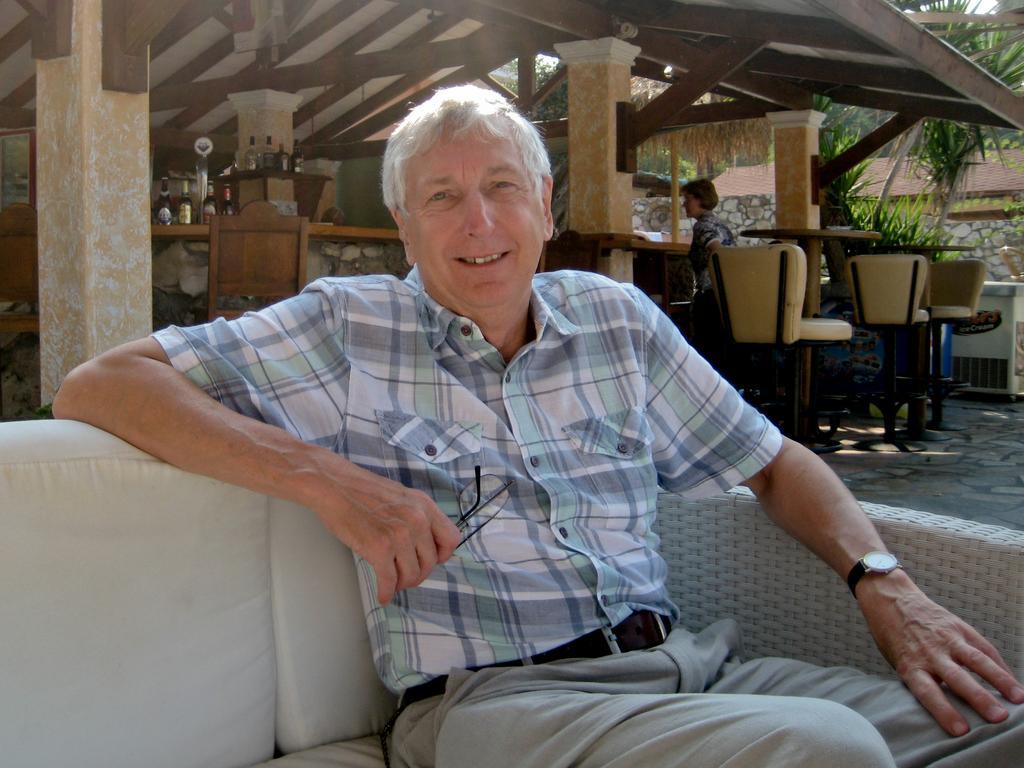How would you summarize this image in a sentence or two? In this image in the foreground there is one person who is sitting on a couch, and he is holding a spectacles. And in the background there are some tables and chairs and some bottles, pillars and one person, trees, house. At the top there is ceiling and some poles, and on the right side there is some object. 